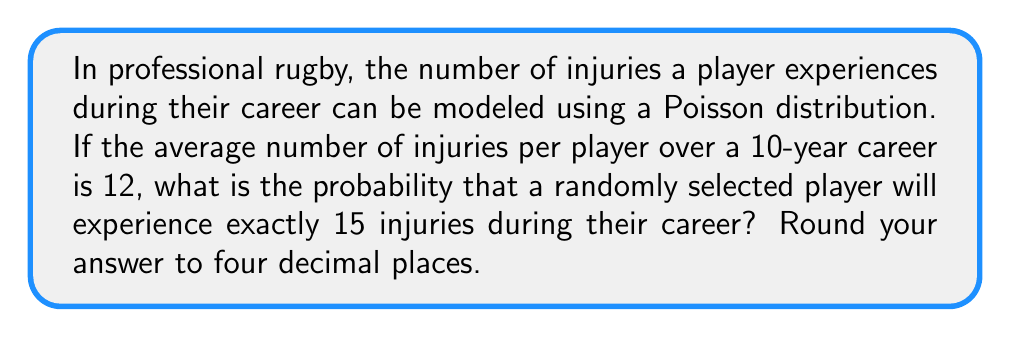Show me your answer to this math problem. Let's approach this step-by-step:

1) The Poisson distribution is given by the formula:

   $$P(X = k) = \frac{e^{-\lambda} \lambda^k}{k!}$$

   Where:
   - $\lambda$ is the average number of events in the given interval
   - $k$ is the number of events we're interested in
   - $e$ is Euler's number (approximately 2.71828)

2) In this case:
   - $\lambda = 12$ (average number of injuries over a 10-year career)
   - $k = 15$ (we're interested in exactly 15 injuries)

3) Let's substitute these values into the formula:

   $$P(X = 15) = \frac{e^{-12} 12^{15}}{15!}$$

4) Now, let's calculate this step-by-step:

   a) First, calculate $e^{-12}$:
      $e^{-12} \approx 6.14421 \times 10^{-6}$

   b) Next, calculate $12^{15}$:
      $12^{15} = 1.29746 \times 10^{16}$

   c) Calculate 15!:
      $15! = 1,307,674,368,000$

   d) Multiply the numerator:
      $6.14421 \times 10^{-6} \times 1.29746 \times 10^{16} = 79.7163$

   e) Divide by the denominator:
      $\frac{79.7163}{1,307,674,368,000} \approx 0.0000609616$

5) Rounding to four decimal places:
   0.0610
Answer: 0.0610 